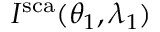Convert formula to latex. <formula><loc_0><loc_0><loc_500><loc_500>I ^ { s c a } ( \theta _ { 1 } , \lambda _ { 1 } )</formula> 